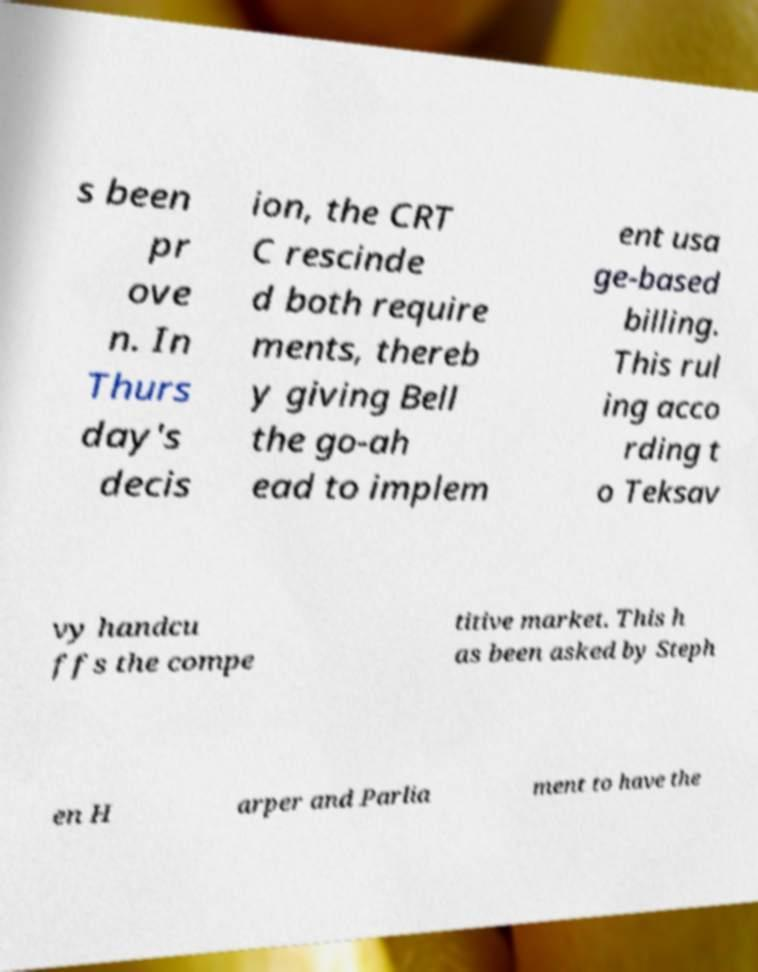Please identify and transcribe the text found in this image. s been pr ove n. In Thurs day's decis ion, the CRT C rescinde d both require ments, thereb y giving Bell the go-ah ead to implem ent usa ge-based billing. This rul ing acco rding t o Teksav vy handcu ffs the compe titive market. This h as been asked by Steph en H arper and Parlia ment to have the 